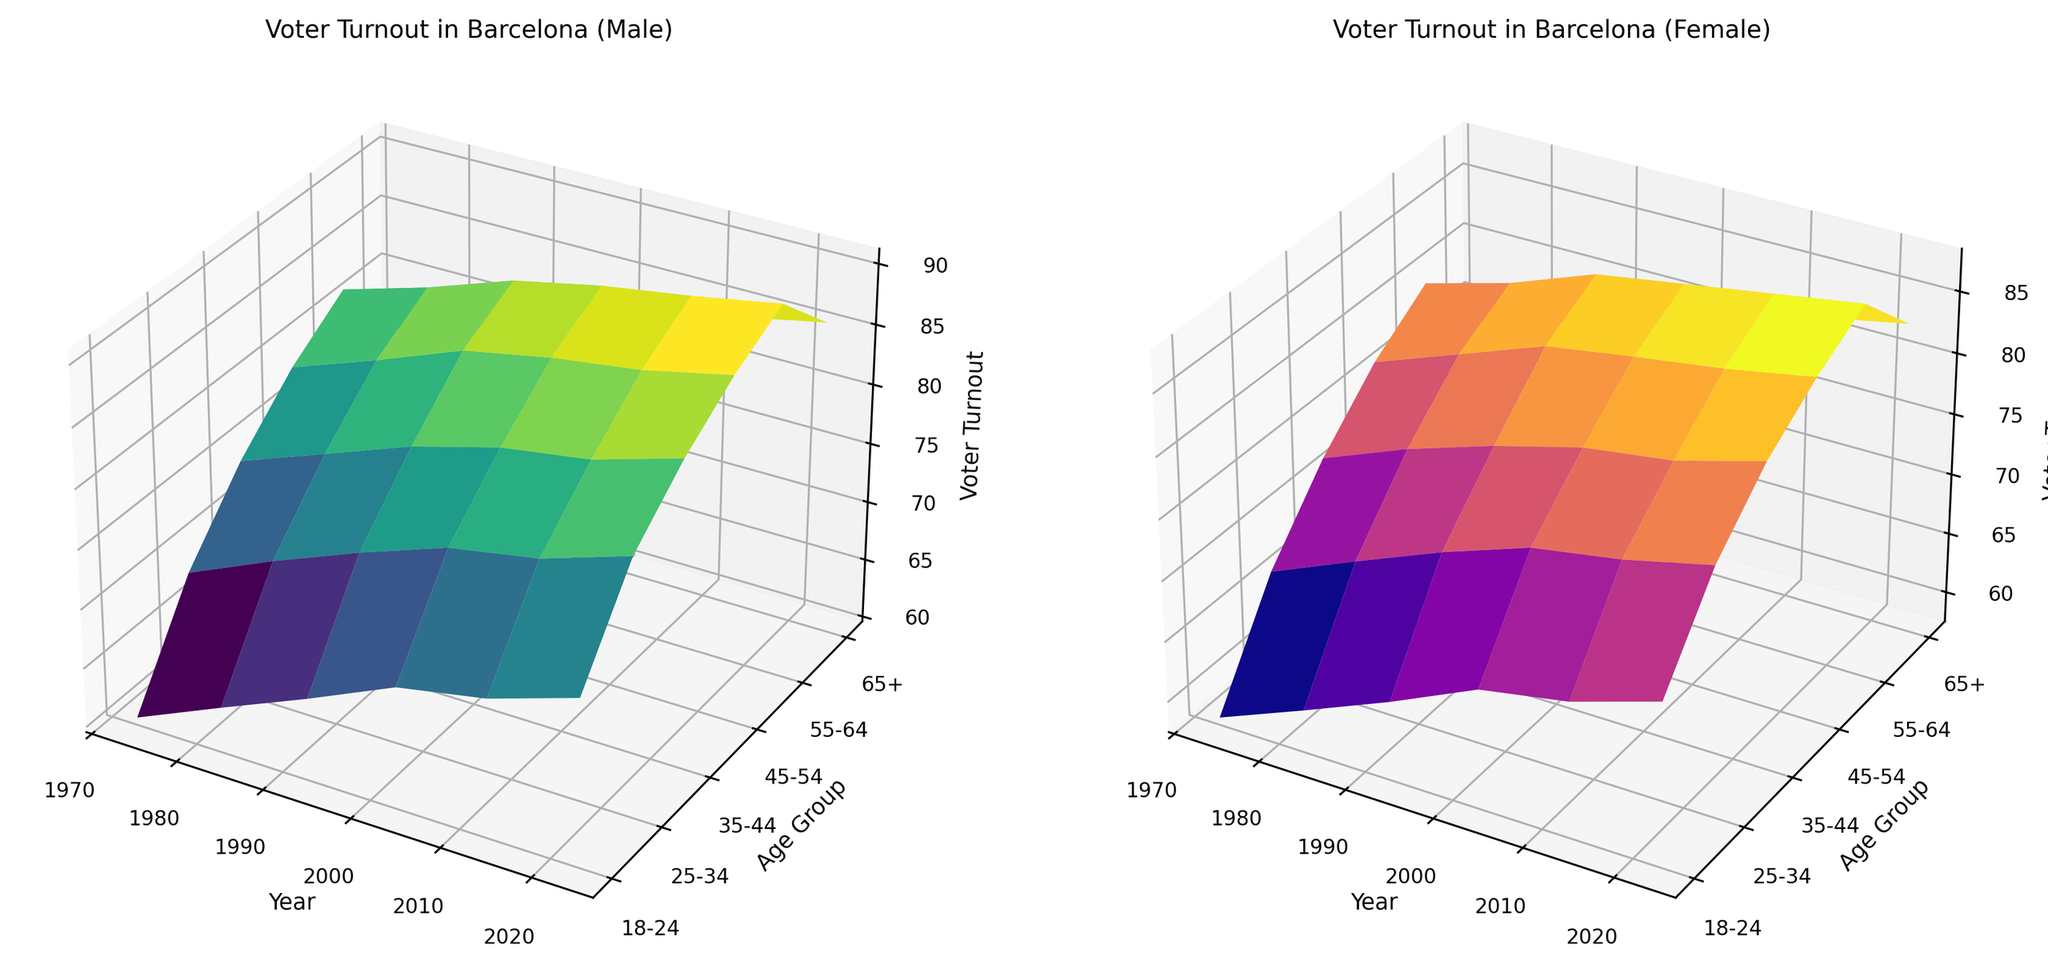How has the voter turnout trend for males aged 18-24 in Barcelona changed from 1973 to 2023? First, find the male voter turnout for the age group 18-24 in 1973 and 2023 in the respective plot. The data points show an increase from around 60.2% in 1973 to around 73.6% in 2023.
Answer: Increased Between 1973 and 2023, in which age group do women in Barcelona show the greatest increase in voter turnout? Examine the female voter turnout across all age groups in Barcelona from the years 1973 to 2023. Look for the group with the most significant change. The 55-64 age group shows an increase from approximately 80.0% to 87.8%, a 7.8% increase.
Answer: 55-64 In 2013, compare the voter turnout for males and females aged 35-44 in Barcelona. Check the voter turnout for the age group 35-44 for both males and females in 2013 in Barcelona plots. The male turnout is around 83.0% while the female turnout is around 80.3%.
Answer: Males have higher turnout What is the difference in voter turnout for Barcelona females aged 65+ between 1973 and 2023? For females aged 65+ in Barcelona, find the voter turnout in 1973 and 2023 from the female plot. Subtract the earlier value from the later one: 82.9% - 73.6% = 9.3%.
Answer: 9.3% Which group had the highest voter turnout in Barcelona in 2023, and what was the turnout rate? Look at the highest points in both the male and female plots for 2023. The highest is for males aged 55-64 with a rate of around 90.6%.
Answer: Males aged 55-64, 90.6% Compare the voter turnout for males and females aged 25-34 in Madrid in 1993. Which gender had higher turnout? Find the voter turnout values for the 25-34 age group in the Madrid plots for males and females in 1993. Males had around 72.6% while females had around 70.1%.
Answer: Males What trend do we observe for voter turnout among Barcelona females aged 45-54 from 1973 to 2023? Observe the changes in voter turnout for Barcelona females aged 45-54 from 1973 to 2023. The values increase from around 76.8% in 1973 to 85.4% in 2023, showing an upward trend.
Answer: Increasing trend Identify the year when females aged 55-64 in Barcelona first reached a voter turnout of at least 85%. Look through the data points for the female plot for Barcelona aged 55-64 and identify the first year the value crosses or meets 85%. The value first reaches 85% in 2013.
Answer: 2013 Between 1993 and 2003, which age group for males in Madrid showed the least change in voter turnout? Compare male voter turnout in Madrid for all age groups between 1993 to 2003. The 45-54 age group shows minimal change, from around 81.5% to 84.6%, a difference of 3.1%.
Answer: 45-54 How does the voter turnout for males aged 25-34 in Barcelona in 2013 compare to 1993? Find the voter turnout for males aged 25-34 in Barcelona in both 1993 and 2013 in the male plot. The turnout increased from around 74.8% in 1993 to around 78.7% in 2013.
Answer: Increased 